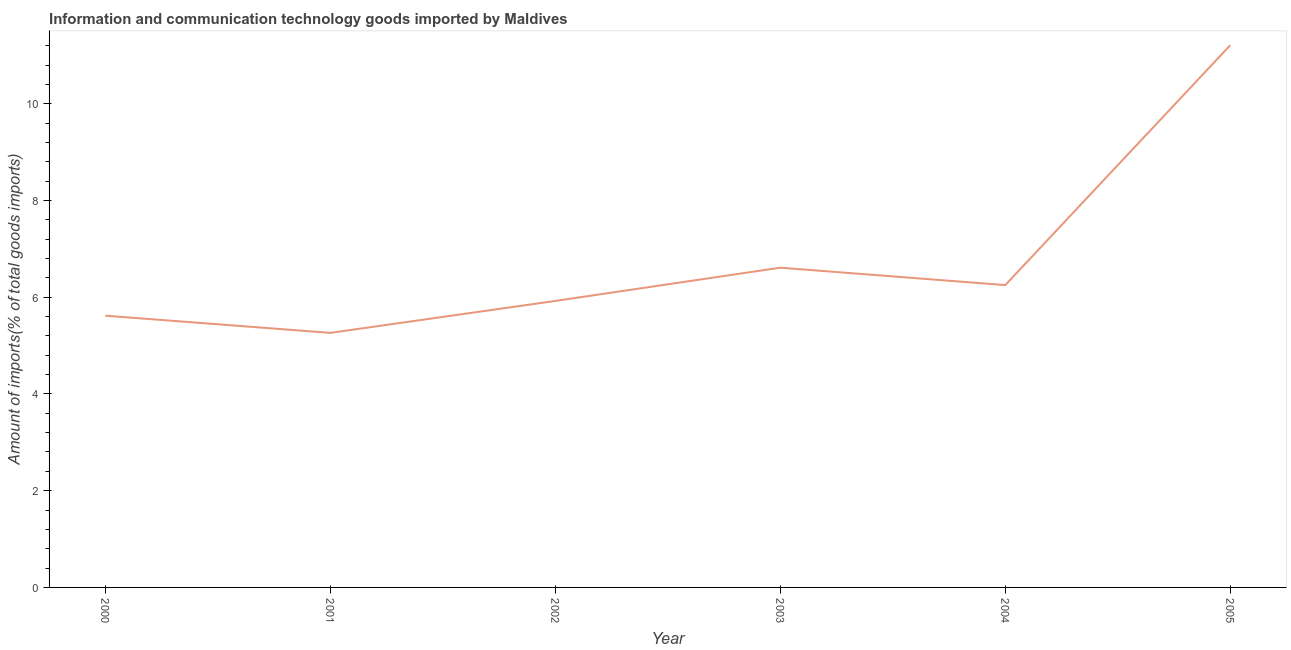What is the amount of ict goods imports in 2002?
Give a very brief answer. 5.92. Across all years, what is the maximum amount of ict goods imports?
Offer a terse response. 11.21. Across all years, what is the minimum amount of ict goods imports?
Your answer should be compact. 5.26. What is the sum of the amount of ict goods imports?
Your response must be concise. 40.87. What is the difference between the amount of ict goods imports in 2001 and 2005?
Your answer should be very brief. -5.95. What is the average amount of ict goods imports per year?
Ensure brevity in your answer.  6.81. What is the median amount of ict goods imports?
Provide a succinct answer. 6.09. Do a majority of the years between 2001 and 2004 (inclusive) have amount of ict goods imports greater than 8.8 %?
Ensure brevity in your answer.  No. What is the ratio of the amount of ict goods imports in 2002 to that in 2003?
Ensure brevity in your answer.  0.9. Is the amount of ict goods imports in 2001 less than that in 2003?
Your answer should be compact. Yes. What is the difference between the highest and the second highest amount of ict goods imports?
Offer a very short reply. 4.6. What is the difference between the highest and the lowest amount of ict goods imports?
Your answer should be very brief. 5.95. In how many years, is the amount of ict goods imports greater than the average amount of ict goods imports taken over all years?
Offer a very short reply. 1. How many lines are there?
Provide a succinct answer. 1. What is the difference between two consecutive major ticks on the Y-axis?
Offer a very short reply. 2. Does the graph contain grids?
Your answer should be compact. No. What is the title of the graph?
Provide a short and direct response. Information and communication technology goods imported by Maldives. What is the label or title of the Y-axis?
Offer a very short reply. Amount of imports(% of total goods imports). What is the Amount of imports(% of total goods imports) of 2000?
Your response must be concise. 5.62. What is the Amount of imports(% of total goods imports) in 2001?
Offer a very short reply. 5.26. What is the Amount of imports(% of total goods imports) in 2002?
Offer a very short reply. 5.92. What is the Amount of imports(% of total goods imports) of 2003?
Make the answer very short. 6.61. What is the Amount of imports(% of total goods imports) in 2004?
Provide a short and direct response. 6.25. What is the Amount of imports(% of total goods imports) of 2005?
Provide a succinct answer. 11.21. What is the difference between the Amount of imports(% of total goods imports) in 2000 and 2001?
Your response must be concise. 0.36. What is the difference between the Amount of imports(% of total goods imports) in 2000 and 2002?
Offer a very short reply. -0.31. What is the difference between the Amount of imports(% of total goods imports) in 2000 and 2003?
Keep it short and to the point. -0.99. What is the difference between the Amount of imports(% of total goods imports) in 2000 and 2004?
Your answer should be compact. -0.63. What is the difference between the Amount of imports(% of total goods imports) in 2000 and 2005?
Offer a terse response. -5.59. What is the difference between the Amount of imports(% of total goods imports) in 2001 and 2002?
Ensure brevity in your answer.  -0.66. What is the difference between the Amount of imports(% of total goods imports) in 2001 and 2003?
Offer a terse response. -1.35. What is the difference between the Amount of imports(% of total goods imports) in 2001 and 2004?
Provide a short and direct response. -0.99. What is the difference between the Amount of imports(% of total goods imports) in 2001 and 2005?
Keep it short and to the point. -5.95. What is the difference between the Amount of imports(% of total goods imports) in 2002 and 2003?
Offer a terse response. -0.69. What is the difference between the Amount of imports(% of total goods imports) in 2002 and 2004?
Offer a terse response. -0.33. What is the difference between the Amount of imports(% of total goods imports) in 2002 and 2005?
Give a very brief answer. -5.29. What is the difference between the Amount of imports(% of total goods imports) in 2003 and 2004?
Offer a terse response. 0.36. What is the difference between the Amount of imports(% of total goods imports) in 2003 and 2005?
Ensure brevity in your answer.  -4.6. What is the difference between the Amount of imports(% of total goods imports) in 2004 and 2005?
Offer a terse response. -4.96. What is the ratio of the Amount of imports(% of total goods imports) in 2000 to that in 2001?
Give a very brief answer. 1.07. What is the ratio of the Amount of imports(% of total goods imports) in 2000 to that in 2002?
Your answer should be compact. 0.95. What is the ratio of the Amount of imports(% of total goods imports) in 2000 to that in 2003?
Your response must be concise. 0.85. What is the ratio of the Amount of imports(% of total goods imports) in 2000 to that in 2004?
Your response must be concise. 0.9. What is the ratio of the Amount of imports(% of total goods imports) in 2000 to that in 2005?
Your answer should be compact. 0.5. What is the ratio of the Amount of imports(% of total goods imports) in 2001 to that in 2002?
Your answer should be compact. 0.89. What is the ratio of the Amount of imports(% of total goods imports) in 2001 to that in 2003?
Give a very brief answer. 0.8. What is the ratio of the Amount of imports(% of total goods imports) in 2001 to that in 2004?
Keep it short and to the point. 0.84. What is the ratio of the Amount of imports(% of total goods imports) in 2001 to that in 2005?
Offer a terse response. 0.47. What is the ratio of the Amount of imports(% of total goods imports) in 2002 to that in 2003?
Your response must be concise. 0.9. What is the ratio of the Amount of imports(% of total goods imports) in 2002 to that in 2004?
Offer a very short reply. 0.95. What is the ratio of the Amount of imports(% of total goods imports) in 2002 to that in 2005?
Offer a very short reply. 0.53. What is the ratio of the Amount of imports(% of total goods imports) in 2003 to that in 2004?
Your answer should be very brief. 1.06. What is the ratio of the Amount of imports(% of total goods imports) in 2003 to that in 2005?
Give a very brief answer. 0.59. What is the ratio of the Amount of imports(% of total goods imports) in 2004 to that in 2005?
Make the answer very short. 0.56. 